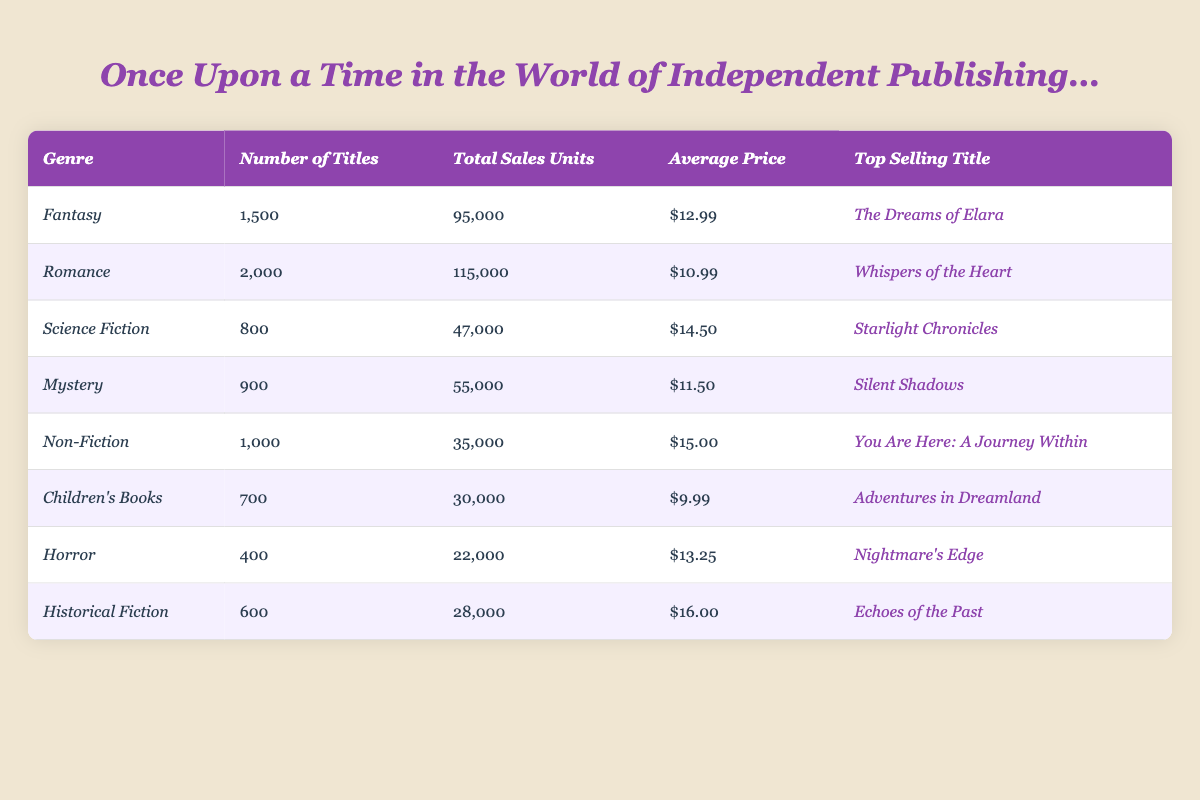What is the genre with the most titles? By reviewing the table, the genre with the highest number of titles is Romance, with 2,000 titles listed.
Answer: Romance Which genre had the highest total sales units in 2023? Looking at the total sales units column, Romance again stands out with 115,000 total sales units, making it the highest.
Answer: Romance How much is the average price of Children's Books? The average price of Children's Books is listed as $9.99 in the respective row of the table.
Answer: $9.99 What is the top-selling title in the Fantasy genre? Referring to the Fantasy row, the top-selling title is "The Dreams of Elara."
Answer: The Dreams of Elara How many total sales units were sold for Science Fiction books? According to the table, 47,000 total sales units were sold for Science Fiction books.
Answer: 47,000 What is the combined total sales units of both Horror and Historical Fiction? To find the combined total, we add the sales units of Horror (22,000) and Historical Fiction (28,000), resulting in 50,000 total sales units.
Answer: 50,000 Is the average price of Non-Fiction books higher than that of Mystery books? The average price of Non-Fiction is $15.00, while Mystery is $11.50. Since $15.00 is greater than $11.50, the statement is true.
Answer: Yes What is the difference in total sales units between Fantasy and Non-Fiction genres? To calculate the difference, we subtract the total sales of Non-Fiction (35,000) from Fantasy (95,000), resulting in a difference of 60,000 units.
Answer: 60,000 Which genre has a higher average price: Science Fiction or Horror? The average price for Science Fiction is $14.50 and for Horror it's $13.25. Since $14.50 is greater, Science Fiction has a higher average price.
Answer: Science Fiction How many total book titles are there across all genres? We sum the number of titles across all genres: 1500 (Fantasy) + 2000 (Romance) + 800 (Science Fiction) + 900 (Mystery) + 1000 (Non-Fiction) + 700 (Children's Books) + 400 (Horror) + 600 (Historical Fiction) = 6,900 total titles.
Answer: 6,900 